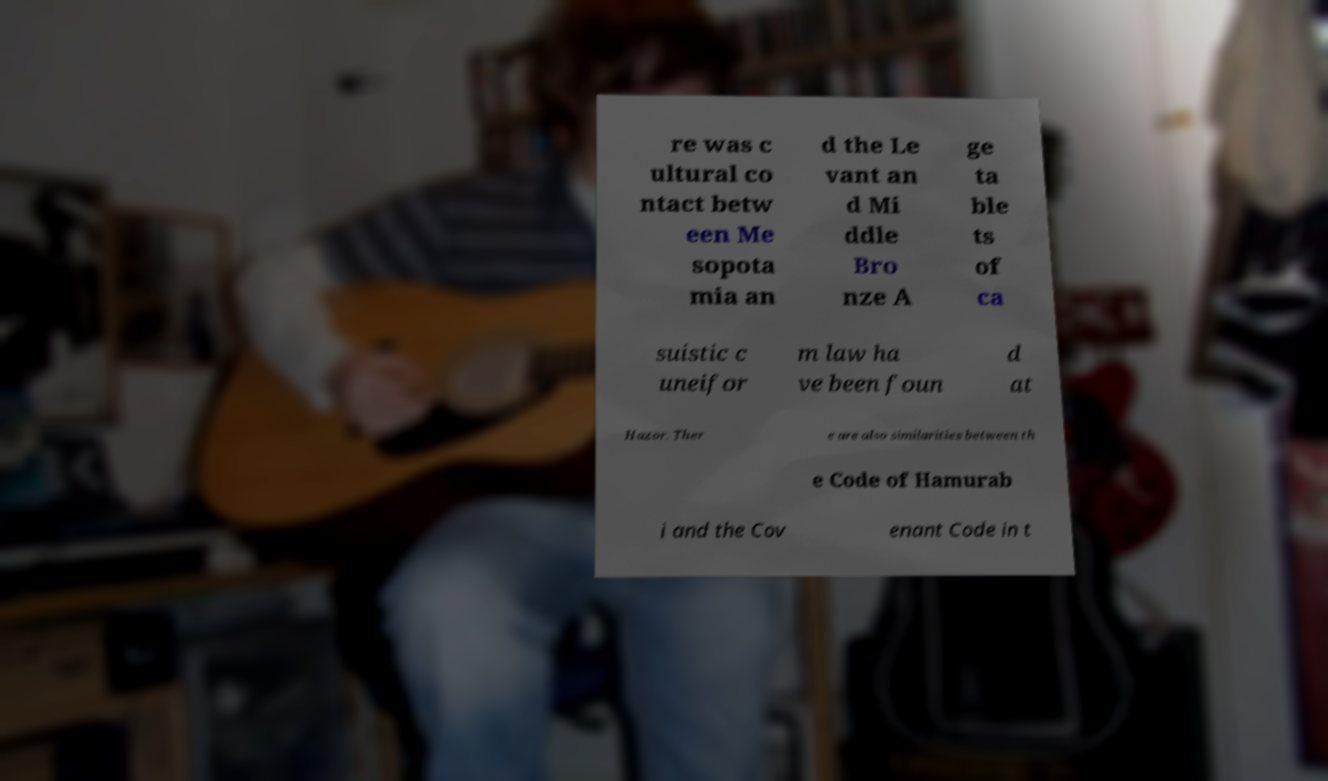What messages or text are displayed in this image? I need them in a readable, typed format. re was c ultural co ntact betw een Me sopota mia an d the Le vant an d Mi ddle Bro nze A ge ta ble ts of ca suistic c uneifor m law ha ve been foun d at Hazor. Ther e are also similarities between th e Code of Hamurab i and the Cov enant Code in t 